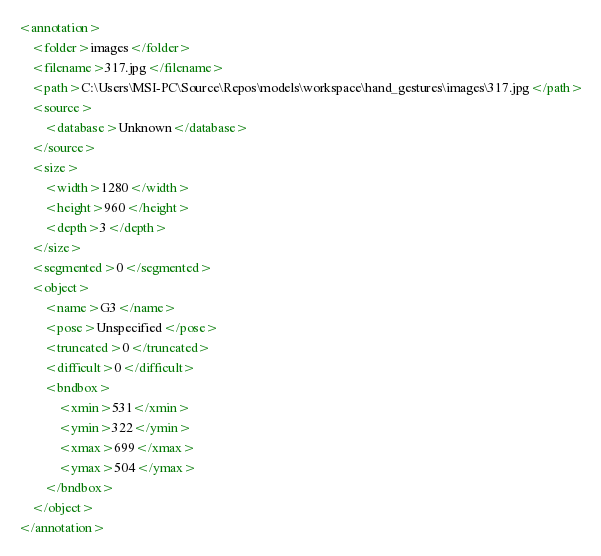Convert code to text. <code><loc_0><loc_0><loc_500><loc_500><_XML_><annotation>
	<folder>images</folder>
	<filename>317.jpg</filename>
	<path>C:\Users\MSI-PC\Source\Repos\models\workspace\hand_gestures\images\317.jpg</path>
	<source>
		<database>Unknown</database>
	</source>
	<size>
		<width>1280</width>
		<height>960</height>
		<depth>3</depth>
	</size>
	<segmented>0</segmented>
	<object>
		<name>G3</name>
		<pose>Unspecified</pose>
		<truncated>0</truncated>
		<difficult>0</difficult>
		<bndbox>
			<xmin>531</xmin>
			<ymin>322</ymin>
			<xmax>699</xmax>
			<ymax>504</ymax>
		</bndbox>
	</object>
</annotation>
</code> 